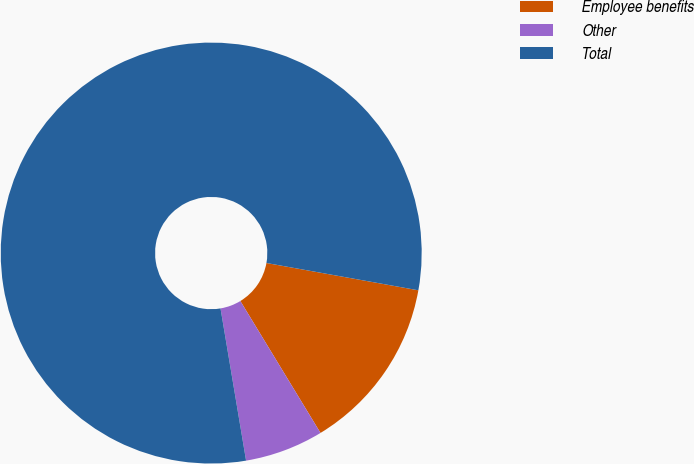Convert chart. <chart><loc_0><loc_0><loc_500><loc_500><pie_chart><fcel>Employee benefits<fcel>Other<fcel>Total<nl><fcel>13.48%<fcel>6.04%<fcel>80.48%<nl></chart> 